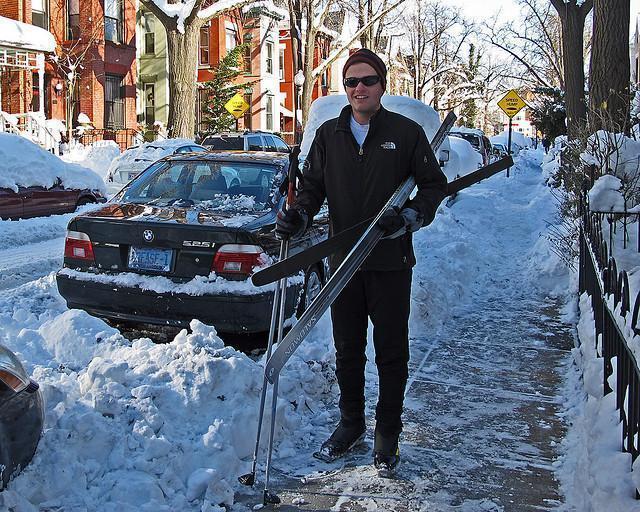How did this man get to this location immediately prior to taking this picture?
From the following set of four choices, select the accurate answer to respond to the question.
Options: Skied, walked, flew, jogged. Walked. 